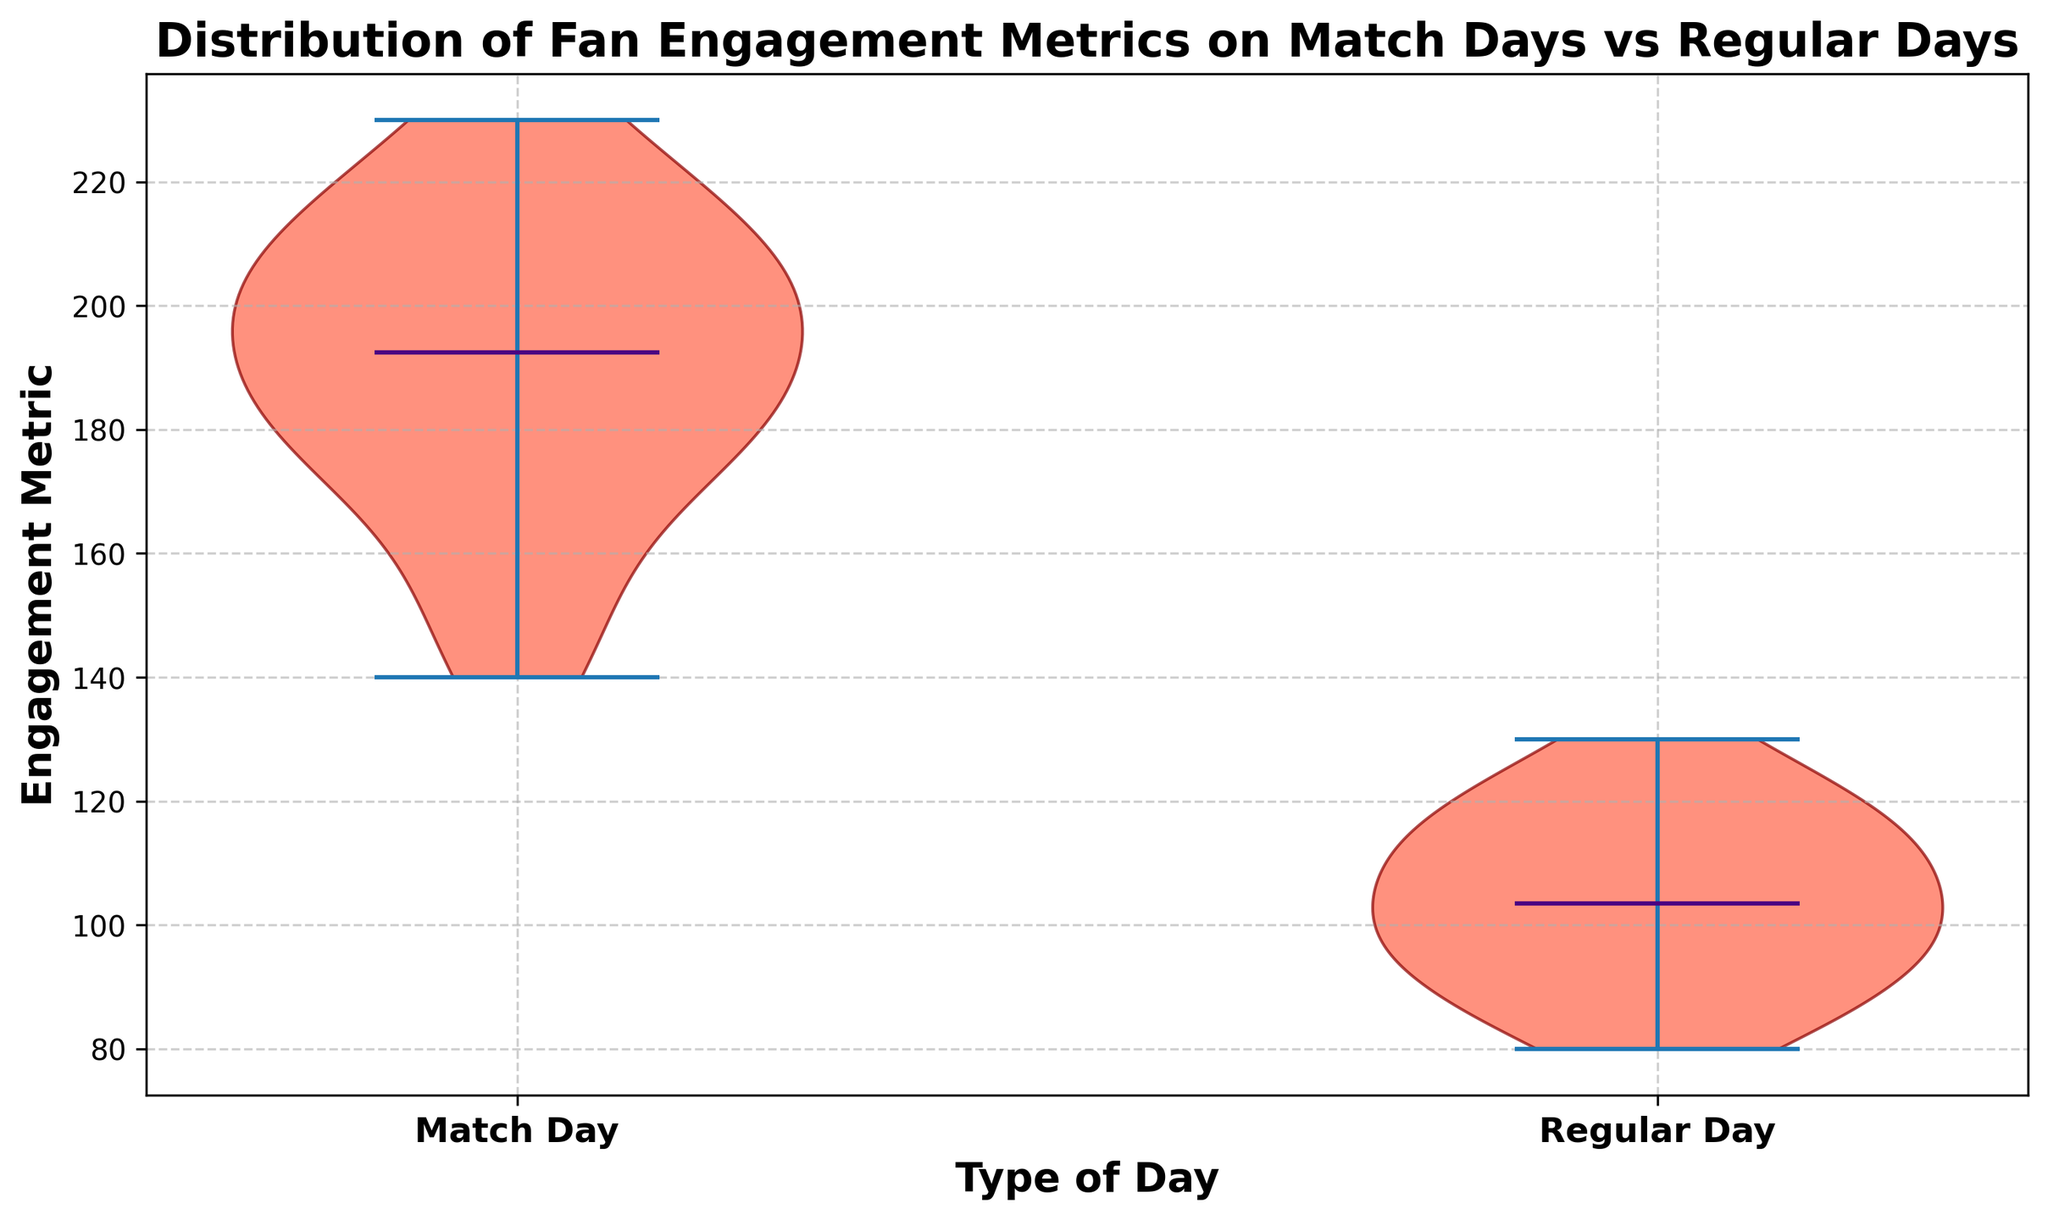What's the range of engagement metrics on Match Days? The range is the difference between the maximum and minimum values. From the figure, the maximum engagement metric for Match Days is around 230, and the minimum is around 140. Therefore, the range is 230 - 140.
Answer: 90 Which day type has a higher median engagement metric? From the figure, the median is marked on each violin plot. The median for Match Days appears higher than that for Regular Days.
Answer: Match Day Which day type shows a wider spread of engagement metrics? The spread can be judged by the width of the violin plot. The violin plot for Match Days appears wider, indicating a greater spread compared to Regular Days.
Answer: Match Day What's the approximate median value of the engagement metric on Regular Days? The median is marked in the center of the Regular Days violin plot. It appears to be close to the line at around 105.
Answer: 105 How does the distribution of engagement metrics on Match Days compare to Regular Days? The Match Days distribution is much wider, indicating higher variability. The engagement metrics for Regular Days are more tightly clustered. Additionally, the median engagement is higher on Match Days.
Answer: More variable on Match Days, higher median Are there any extreme engagement values in the data? Extreme values or outliers typically appear as points outside the main bulk of the violin plot. No extreme points are visible on either violin plot, indicating no significant outliers.
Answer: No What is the color and opacity of the violin plot bodies? The bodies of the violin plots are filled with a color that appears to be red, and they have a partial transparency (are semi-transparent).
Answer: Red and semi-transparent 